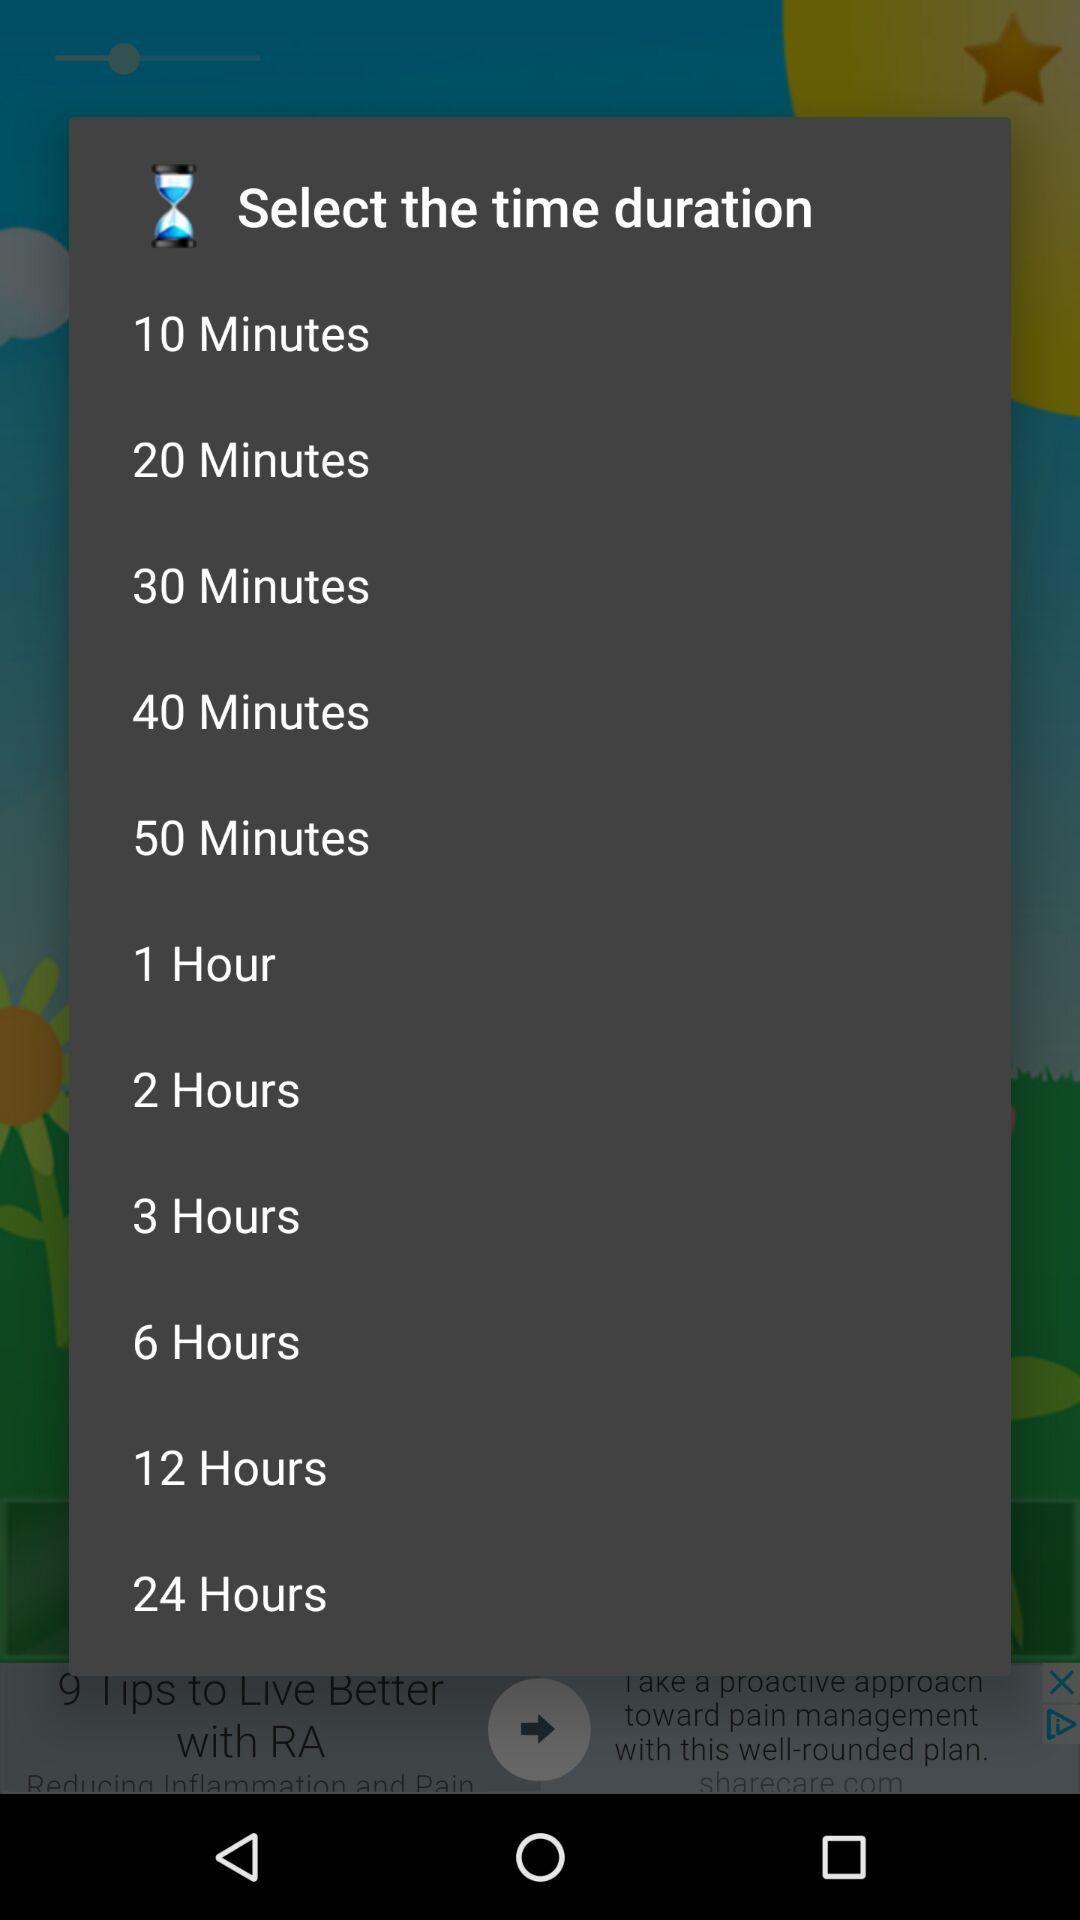What is the minimum time duration? The time duration is 10 minutes. 